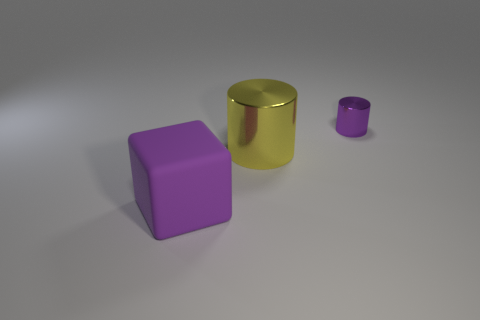What shape is the big object that is to the right of the big thing in front of the large metallic thing that is left of the tiny metallic cylinder?
Ensure brevity in your answer.  Cylinder. The metal thing to the left of the metal object that is right of the big yellow shiny thing is what shape?
Offer a terse response. Cylinder. Are there any purple objects that have the same material as the big yellow cylinder?
Offer a very short reply. Yes. There is a matte block that is the same color as the tiny metal object; what is its size?
Give a very brief answer. Large. What number of purple things are either metal cylinders or large matte spheres?
Keep it short and to the point. 1. Is there another big thing of the same color as the large rubber thing?
Your response must be concise. No. What size is the cylinder that is the same material as the yellow thing?
Give a very brief answer. Small. How many cylinders are purple rubber things or tiny purple metal objects?
Your answer should be compact. 1. Are there more rubber objects than purple shiny spheres?
Provide a short and direct response. Yes. What number of matte objects have the same size as the purple shiny thing?
Keep it short and to the point. 0. 